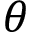<formula> <loc_0><loc_0><loc_500><loc_500>\theta</formula> 